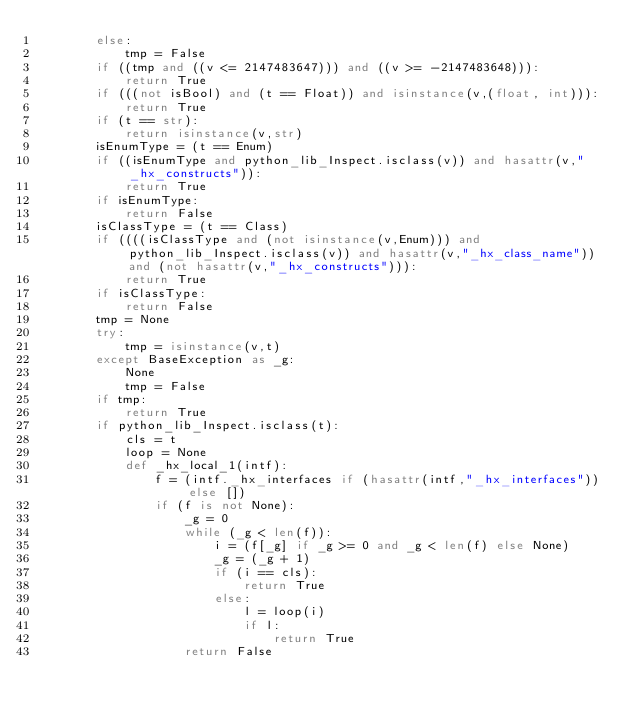<code> <loc_0><loc_0><loc_500><loc_500><_Python_>        else:
            tmp = False
        if ((tmp and ((v <= 2147483647))) and ((v >= -2147483648))):
            return True
        if (((not isBool) and (t == Float)) and isinstance(v,(float, int))):
            return True
        if (t == str):
            return isinstance(v,str)
        isEnumType = (t == Enum)
        if ((isEnumType and python_lib_Inspect.isclass(v)) and hasattr(v,"_hx_constructs")):
            return True
        if isEnumType:
            return False
        isClassType = (t == Class)
        if ((((isClassType and (not isinstance(v,Enum))) and python_lib_Inspect.isclass(v)) and hasattr(v,"_hx_class_name")) and (not hasattr(v,"_hx_constructs"))):
            return True
        if isClassType:
            return False
        tmp = None
        try:
            tmp = isinstance(v,t)
        except BaseException as _g:
            None
            tmp = False
        if tmp:
            return True
        if python_lib_Inspect.isclass(t):
            cls = t
            loop = None
            def _hx_local_1(intf):
                f = (intf._hx_interfaces if (hasattr(intf,"_hx_interfaces")) else [])
                if (f is not None):
                    _g = 0
                    while (_g < len(f)):
                        i = (f[_g] if _g >= 0 and _g < len(f) else None)
                        _g = (_g + 1)
                        if (i == cls):
                            return True
                        else:
                            l = loop(i)
                            if l:
                                return True
                    return False</code> 